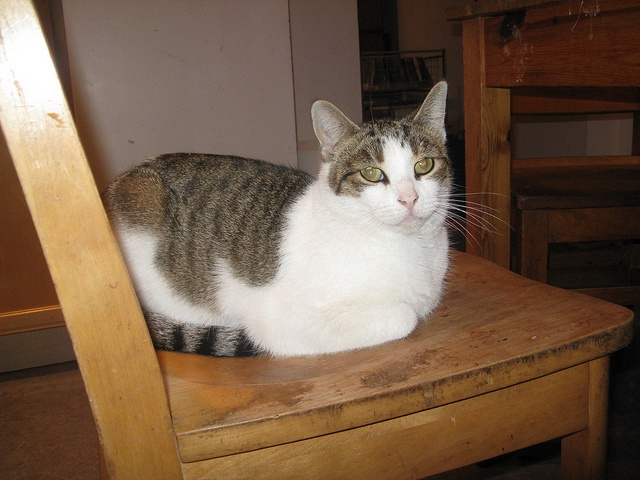Describe the objects in this image and their specific colors. I can see chair in tan, olive, maroon, and gray tones, cat in tan, lightgray, gray, and darkgray tones, dining table in tan, maroon, black, and gray tones, chair in black, maroon, and tan tones, and book in black and tan tones in this image. 